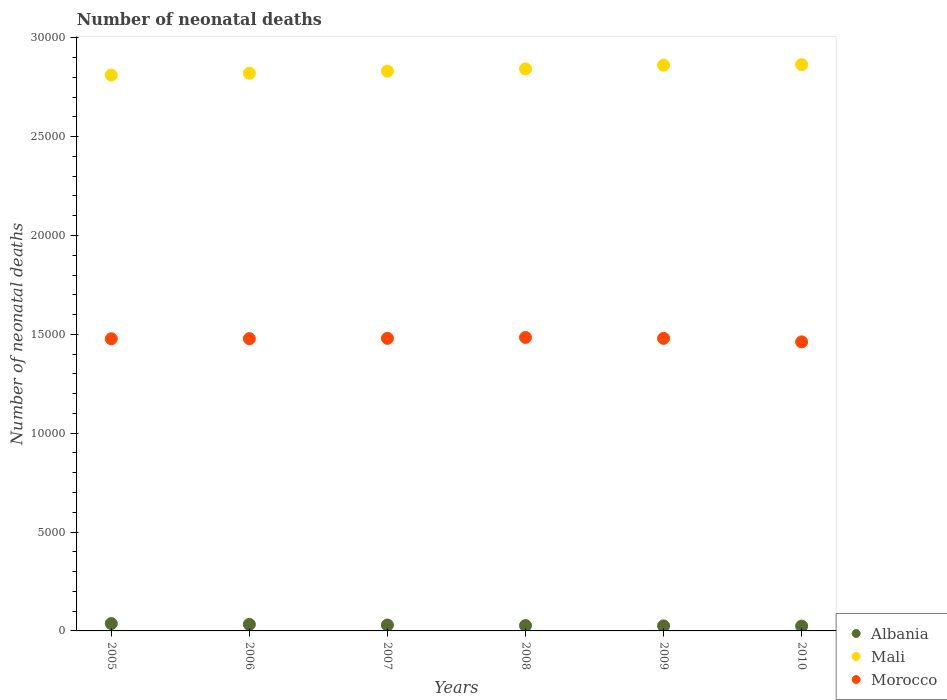How many different coloured dotlines are there?
Give a very brief answer. 3. Is the number of dotlines equal to the number of legend labels?
Keep it short and to the point. Yes. What is the number of neonatal deaths in in Mali in 2006?
Offer a terse response. 2.82e+04. Across all years, what is the maximum number of neonatal deaths in in Mali?
Make the answer very short. 2.86e+04. Across all years, what is the minimum number of neonatal deaths in in Mali?
Ensure brevity in your answer.  2.81e+04. In which year was the number of neonatal deaths in in Mali minimum?
Give a very brief answer. 2005. What is the total number of neonatal deaths in in Morocco in the graph?
Your answer should be very brief. 8.86e+04. What is the difference between the number of neonatal deaths in in Mali in 2006 and that in 2009?
Offer a very short reply. -407. What is the difference between the number of neonatal deaths in in Morocco in 2006 and the number of neonatal deaths in in Mali in 2007?
Your response must be concise. -1.35e+04. What is the average number of neonatal deaths in in Morocco per year?
Give a very brief answer. 1.48e+04. In the year 2008, what is the difference between the number of neonatal deaths in in Albania and number of neonatal deaths in in Morocco?
Provide a short and direct response. -1.46e+04. In how many years, is the number of neonatal deaths in in Albania greater than 25000?
Your answer should be compact. 0. What is the ratio of the number of neonatal deaths in in Morocco in 2006 to that in 2008?
Provide a succinct answer. 1. What is the difference between the highest and the second highest number of neonatal deaths in in Morocco?
Offer a very short reply. 44. What is the difference between the highest and the lowest number of neonatal deaths in in Albania?
Keep it short and to the point. 128. In how many years, is the number of neonatal deaths in in Mali greater than the average number of neonatal deaths in in Mali taken over all years?
Your response must be concise. 3. Is the sum of the number of neonatal deaths in in Morocco in 2008 and 2009 greater than the maximum number of neonatal deaths in in Mali across all years?
Your answer should be compact. Yes. Is it the case that in every year, the sum of the number of neonatal deaths in in Albania and number of neonatal deaths in in Mali  is greater than the number of neonatal deaths in in Morocco?
Make the answer very short. Yes. Does the number of neonatal deaths in in Mali monotonically increase over the years?
Offer a terse response. Yes. What is the difference between two consecutive major ticks on the Y-axis?
Offer a terse response. 5000. Are the values on the major ticks of Y-axis written in scientific E-notation?
Offer a very short reply. No. Where does the legend appear in the graph?
Make the answer very short. Bottom right. How many legend labels are there?
Your answer should be compact. 3. How are the legend labels stacked?
Your answer should be very brief. Vertical. What is the title of the graph?
Your response must be concise. Number of neonatal deaths. Does "Pacific island small states" appear as one of the legend labels in the graph?
Offer a terse response. No. What is the label or title of the X-axis?
Your answer should be very brief. Years. What is the label or title of the Y-axis?
Ensure brevity in your answer.  Number of neonatal deaths. What is the Number of neonatal deaths of Albania in 2005?
Offer a terse response. 372. What is the Number of neonatal deaths of Mali in 2005?
Your answer should be compact. 2.81e+04. What is the Number of neonatal deaths in Morocco in 2005?
Provide a short and direct response. 1.48e+04. What is the Number of neonatal deaths in Albania in 2006?
Give a very brief answer. 331. What is the Number of neonatal deaths in Mali in 2006?
Keep it short and to the point. 2.82e+04. What is the Number of neonatal deaths in Morocco in 2006?
Make the answer very short. 1.48e+04. What is the Number of neonatal deaths in Albania in 2007?
Your response must be concise. 297. What is the Number of neonatal deaths of Mali in 2007?
Provide a succinct answer. 2.83e+04. What is the Number of neonatal deaths in Morocco in 2007?
Give a very brief answer. 1.48e+04. What is the Number of neonatal deaths in Albania in 2008?
Ensure brevity in your answer.  271. What is the Number of neonatal deaths of Mali in 2008?
Your response must be concise. 2.84e+04. What is the Number of neonatal deaths of Morocco in 2008?
Provide a short and direct response. 1.48e+04. What is the Number of neonatal deaths of Albania in 2009?
Your response must be concise. 254. What is the Number of neonatal deaths in Mali in 2009?
Your answer should be very brief. 2.86e+04. What is the Number of neonatal deaths in Morocco in 2009?
Provide a succinct answer. 1.48e+04. What is the Number of neonatal deaths of Albania in 2010?
Your answer should be compact. 244. What is the Number of neonatal deaths in Mali in 2010?
Ensure brevity in your answer.  2.86e+04. What is the Number of neonatal deaths in Morocco in 2010?
Provide a succinct answer. 1.46e+04. Across all years, what is the maximum Number of neonatal deaths in Albania?
Keep it short and to the point. 372. Across all years, what is the maximum Number of neonatal deaths of Mali?
Offer a very short reply. 2.86e+04. Across all years, what is the maximum Number of neonatal deaths of Morocco?
Offer a terse response. 1.48e+04. Across all years, what is the minimum Number of neonatal deaths of Albania?
Provide a succinct answer. 244. Across all years, what is the minimum Number of neonatal deaths in Mali?
Your answer should be compact. 2.81e+04. Across all years, what is the minimum Number of neonatal deaths of Morocco?
Give a very brief answer. 1.46e+04. What is the total Number of neonatal deaths in Albania in the graph?
Provide a succinct answer. 1769. What is the total Number of neonatal deaths of Mali in the graph?
Offer a very short reply. 1.70e+05. What is the total Number of neonatal deaths of Morocco in the graph?
Your answer should be very brief. 8.86e+04. What is the difference between the Number of neonatal deaths of Mali in 2005 and that in 2006?
Your answer should be very brief. -95. What is the difference between the Number of neonatal deaths of Mali in 2005 and that in 2007?
Offer a terse response. -200. What is the difference between the Number of neonatal deaths of Albania in 2005 and that in 2008?
Provide a short and direct response. 101. What is the difference between the Number of neonatal deaths in Mali in 2005 and that in 2008?
Provide a succinct answer. -315. What is the difference between the Number of neonatal deaths in Morocco in 2005 and that in 2008?
Your response must be concise. -66. What is the difference between the Number of neonatal deaths of Albania in 2005 and that in 2009?
Your answer should be very brief. 118. What is the difference between the Number of neonatal deaths in Mali in 2005 and that in 2009?
Offer a terse response. -502. What is the difference between the Number of neonatal deaths of Albania in 2005 and that in 2010?
Make the answer very short. 128. What is the difference between the Number of neonatal deaths of Mali in 2005 and that in 2010?
Your answer should be very brief. -530. What is the difference between the Number of neonatal deaths in Morocco in 2005 and that in 2010?
Keep it short and to the point. 157. What is the difference between the Number of neonatal deaths of Albania in 2006 and that in 2007?
Offer a terse response. 34. What is the difference between the Number of neonatal deaths of Mali in 2006 and that in 2007?
Keep it short and to the point. -105. What is the difference between the Number of neonatal deaths in Mali in 2006 and that in 2008?
Your answer should be very brief. -220. What is the difference between the Number of neonatal deaths of Morocco in 2006 and that in 2008?
Offer a terse response. -60. What is the difference between the Number of neonatal deaths in Albania in 2006 and that in 2009?
Provide a short and direct response. 77. What is the difference between the Number of neonatal deaths of Mali in 2006 and that in 2009?
Provide a succinct answer. -407. What is the difference between the Number of neonatal deaths of Morocco in 2006 and that in 2009?
Make the answer very short. -16. What is the difference between the Number of neonatal deaths in Albania in 2006 and that in 2010?
Your answer should be compact. 87. What is the difference between the Number of neonatal deaths of Mali in 2006 and that in 2010?
Make the answer very short. -435. What is the difference between the Number of neonatal deaths in Morocco in 2006 and that in 2010?
Offer a very short reply. 163. What is the difference between the Number of neonatal deaths of Mali in 2007 and that in 2008?
Your response must be concise. -115. What is the difference between the Number of neonatal deaths in Morocco in 2007 and that in 2008?
Your answer should be compact. -44. What is the difference between the Number of neonatal deaths of Albania in 2007 and that in 2009?
Offer a terse response. 43. What is the difference between the Number of neonatal deaths in Mali in 2007 and that in 2009?
Offer a terse response. -302. What is the difference between the Number of neonatal deaths of Albania in 2007 and that in 2010?
Offer a very short reply. 53. What is the difference between the Number of neonatal deaths of Mali in 2007 and that in 2010?
Ensure brevity in your answer.  -330. What is the difference between the Number of neonatal deaths in Morocco in 2007 and that in 2010?
Keep it short and to the point. 179. What is the difference between the Number of neonatal deaths of Albania in 2008 and that in 2009?
Your answer should be very brief. 17. What is the difference between the Number of neonatal deaths of Mali in 2008 and that in 2009?
Give a very brief answer. -187. What is the difference between the Number of neonatal deaths of Morocco in 2008 and that in 2009?
Make the answer very short. 44. What is the difference between the Number of neonatal deaths of Albania in 2008 and that in 2010?
Ensure brevity in your answer.  27. What is the difference between the Number of neonatal deaths of Mali in 2008 and that in 2010?
Keep it short and to the point. -215. What is the difference between the Number of neonatal deaths in Morocco in 2008 and that in 2010?
Your response must be concise. 223. What is the difference between the Number of neonatal deaths in Albania in 2009 and that in 2010?
Ensure brevity in your answer.  10. What is the difference between the Number of neonatal deaths in Morocco in 2009 and that in 2010?
Give a very brief answer. 179. What is the difference between the Number of neonatal deaths in Albania in 2005 and the Number of neonatal deaths in Mali in 2006?
Offer a very short reply. -2.78e+04. What is the difference between the Number of neonatal deaths in Albania in 2005 and the Number of neonatal deaths in Morocco in 2006?
Give a very brief answer. -1.44e+04. What is the difference between the Number of neonatal deaths in Mali in 2005 and the Number of neonatal deaths in Morocco in 2006?
Make the answer very short. 1.33e+04. What is the difference between the Number of neonatal deaths of Albania in 2005 and the Number of neonatal deaths of Mali in 2007?
Provide a succinct answer. -2.79e+04. What is the difference between the Number of neonatal deaths in Albania in 2005 and the Number of neonatal deaths in Morocco in 2007?
Provide a succinct answer. -1.44e+04. What is the difference between the Number of neonatal deaths of Mali in 2005 and the Number of neonatal deaths of Morocco in 2007?
Your response must be concise. 1.33e+04. What is the difference between the Number of neonatal deaths of Albania in 2005 and the Number of neonatal deaths of Mali in 2008?
Provide a succinct answer. -2.81e+04. What is the difference between the Number of neonatal deaths in Albania in 2005 and the Number of neonatal deaths in Morocco in 2008?
Offer a very short reply. -1.45e+04. What is the difference between the Number of neonatal deaths in Mali in 2005 and the Number of neonatal deaths in Morocco in 2008?
Offer a terse response. 1.33e+04. What is the difference between the Number of neonatal deaths of Albania in 2005 and the Number of neonatal deaths of Mali in 2009?
Give a very brief answer. -2.82e+04. What is the difference between the Number of neonatal deaths in Albania in 2005 and the Number of neonatal deaths in Morocco in 2009?
Offer a terse response. -1.44e+04. What is the difference between the Number of neonatal deaths of Mali in 2005 and the Number of neonatal deaths of Morocco in 2009?
Make the answer very short. 1.33e+04. What is the difference between the Number of neonatal deaths of Albania in 2005 and the Number of neonatal deaths of Mali in 2010?
Your answer should be compact. -2.83e+04. What is the difference between the Number of neonatal deaths in Albania in 2005 and the Number of neonatal deaths in Morocco in 2010?
Make the answer very short. -1.42e+04. What is the difference between the Number of neonatal deaths in Mali in 2005 and the Number of neonatal deaths in Morocco in 2010?
Provide a short and direct response. 1.35e+04. What is the difference between the Number of neonatal deaths in Albania in 2006 and the Number of neonatal deaths in Mali in 2007?
Provide a succinct answer. -2.80e+04. What is the difference between the Number of neonatal deaths of Albania in 2006 and the Number of neonatal deaths of Morocco in 2007?
Provide a short and direct response. -1.45e+04. What is the difference between the Number of neonatal deaths of Mali in 2006 and the Number of neonatal deaths of Morocco in 2007?
Your answer should be very brief. 1.34e+04. What is the difference between the Number of neonatal deaths of Albania in 2006 and the Number of neonatal deaths of Mali in 2008?
Your answer should be compact. -2.81e+04. What is the difference between the Number of neonatal deaths of Albania in 2006 and the Number of neonatal deaths of Morocco in 2008?
Your answer should be compact. -1.45e+04. What is the difference between the Number of neonatal deaths in Mali in 2006 and the Number of neonatal deaths in Morocco in 2008?
Offer a very short reply. 1.34e+04. What is the difference between the Number of neonatal deaths of Albania in 2006 and the Number of neonatal deaths of Mali in 2009?
Offer a very short reply. -2.83e+04. What is the difference between the Number of neonatal deaths in Albania in 2006 and the Number of neonatal deaths in Morocco in 2009?
Provide a short and direct response. -1.45e+04. What is the difference between the Number of neonatal deaths of Mali in 2006 and the Number of neonatal deaths of Morocco in 2009?
Offer a terse response. 1.34e+04. What is the difference between the Number of neonatal deaths in Albania in 2006 and the Number of neonatal deaths in Mali in 2010?
Provide a short and direct response. -2.83e+04. What is the difference between the Number of neonatal deaths of Albania in 2006 and the Number of neonatal deaths of Morocco in 2010?
Offer a terse response. -1.43e+04. What is the difference between the Number of neonatal deaths of Mali in 2006 and the Number of neonatal deaths of Morocco in 2010?
Provide a succinct answer. 1.36e+04. What is the difference between the Number of neonatal deaths in Albania in 2007 and the Number of neonatal deaths in Mali in 2008?
Make the answer very short. -2.81e+04. What is the difference between the Number of neonatal deaths in Albania in 2007 and the Number of neonatal deaths in Morocco in 2008?
Offer a very short reply. -1.45e+04. What is the difference between the Number of neonatal deaths in Mali in 2007 and the Number of neonatal deaths in Morocco in 2008?
Your answer should be compact. 1.35e+04. What is the difference between the Number of neonatal deaths in Albania in 2007 and the Number of neonatal deaths in Mali in 2009?
Ensure brevity in your answer.  -2.83e+04. What is the difference between the Number of neonatal deaths in Albania in 2007 and the Number of neonatal deaths in Morocco in 2009?
Your response must be concise. -1.45e+04. What is the difference between the Number of neonatal deaths of Mali in 2007 and the Number of neonatal deaths of Morocco in 2009?
Provide a short and direct response. 1.35e+04. What is the difference between the Number of neonatal deaths in Albania in 2007 and the Number of neonatal deaths in Mali in 2010?
Offer a terse response. -2.83e+04. What is the difference between the Number of neonatal deaths of Albania in 2007 and the Number of neonatal deaths of Morocco in 2010?
Your answer should be compact. -1.43e+04. What is the difference between the Number of neonatal deaths in Mali in 2007 and the Number of neonatal deaths in Morocco in 2010?
Ensure brevity in your answer.  1.37e+04. What is the difference between the Number of neonatal deaths in Albania in 2008 and the Number of neonatal deaths in Mali in 2009?
Your answer should be compact. -2.83e+04. What is the difference between the Number of neonatal deaths in Albania in 2008 and the Number of neonatal deaths in Morocco in 2009?
Ensure brevity in your answer.  -1.45e+04. What is the difference between the Number of neonatal deaths of Mali in 2008 and the Number of neonatal deaths of Morocco in 2009?
Keep it short and to the point. 1.36e+04. What is the difference between the Number of neonatal deaths of Albania in 2008 and the Number of neonatal deaths of Mali in 2010?
Your answer should be compact. -2.84e+04. What is the difference between the Number of neonatal deaths of Albania in 2008 and the Number of neonatal deaths of Morocco in 2010?
Your answer should be very brief. -1.43e+04. What is the difference between the Number of neonatal deaths in Mali in 2008 and the Number of neonatal deaths in Morocco in 2010?
Your response must be concise. 1.38e+04. What is the difference between the Number of neonatal deaths in Albania in 2009 and the Number of neonatal deaths in Mali in 2010?
Provide a short and direct response. -2.84e+04. What is the difference between the Number of neonatal deaths in Albania in 2009 and the Number of neonatal deaths in Morocco in 2010?
Provide a short and direct response. -1.44e+04. What is the difference between the Number of neonatal deaths in Mali in 2009 and the Number of neonatal deaths in Morocco in 2010?
Your answer should be compact. 1.40e+04. What is the average Number of neonatal deaths in Albania per year?
Your answer should be very brief. 294.83. What is the average Number of neonatal deaths in Mali per year?
Ensure brevity in your answer.  2.84e+04. What is the average Number of neonatal deaths in Morocco per year?
Make the answer very short. 1.48e+04. In the year 2005, what is the difference between the Number of neonatal deaths in Albania and Number of neonatal deaths in Mali?
Make the answer very short. -2.77e+04. In the year 2005, what is the difference between the Number of neonatal deaths in Albania and Number of neonatal deaths in Morocco?
Ensure brevity in your answer.  -1.44e+04. In the year 2005, what is the difference between the Number of neonatal deaths of Mali and Number of neonatal deaths of Morocco?
Your response must be concise. 1.33e+04. In the year 2006, what is the difference between the Number of neonatal deaths of Albania and Number of neonatal deaths of Mali?
Make the answer very short. -2.79e+04. In the year 2006, what is the difference between the Number of neonatal deaths in Albania and Number of neonatal deaths in Morocco?
Keep it short and to the point. -1.45e+04. In the year 2006, what is the difference between the Number of neonatal deaths of Mali and Number of neonatal deaths of Morocco?
Keep it short and to the point. 1.34e+04. In the year 2007, what is the difference between the Number of neonatal deaths of Albania and Number of neonatal deaths of Mali?
Give a very brief answer. -2.80e+04. In the year 2007, what is the difference between the Number of neonatal deaths in Albania and Number of neonatal deaths in Morocco?
Make the answer very short. -1.45e+04. In the year 2007, what is the difference between the Number of neonatal deaths in Mali and Number of neonatal deaths in Morocco?
Keep it short and to the point. 1.35e+04. In the year 2008, what is the difference between the Number of neonatal deaths of Albania and Number of neonatal deaths of Mali?
Your answer should be compact. -2.82e+04. In the year 2008, what is the difference between the Number of neonatal deaths of Albania and Number of neonatal deaths of Morocco?
Give a very brief answer. -1.46e+04. In the year 2008, what is the difference between the Number of neonatal deaths in Mali and Number of neonatal deaths in Morocco?
Offer a very short reply. 1.36e+04. In the year 2009, what is the difference between the Number of neonatal deaths in Albania and Number of neonatal deaths in Mali?
Your answer should be compact. -2.84e+04. In the year 2009, what is the difference between the Number of neonatal deaths of Albania and Number of neonatal deaths of Morocco?
Your response must be concise. -1.45e+04. In the year 2009, what is the difference between the Number of neonatal deaths in Mali and Number of neonatal deaths in Morocco?
Provide a succinct answer. 1.38e+04. In the year 2010, what is the difference between the Number of neonatal deaths of Albania and Number of neonatal deaths of Mali?
Ensure brevity in your answer.  -2.84e+04. In the year 2010, what is the difference between the Number of neonatal deaths of Albania and Number of neonatal deaths of Morocco?
Give a very brief answer. -1.44e+04. In the year 2010, what is the difference between the Number of neonatal deaths in Mali and Number of neonatal deaths in Morocco?
Give a very brief answer. 1.40e+04. What is the ratio of the Number of neonatal deaths of Albania in 2005 to that in 2006?
Offer a terse response. 1.12. What is the ratio of the Number of neonatal deaths in Albania in 2005 to that in 2007?
Offer a terse response. 1.25. What is the ratio of the Number of neonatal deaths of Morocco in 2005 to that in 2007?
Ensure brevity in your answer.  1. What is the ratio of the Number of neonatal deaths in Albania in 2005 to that in 2008?
Offer a very short reply. 1.37. What is the ratio of the Number of neonatal deaths of Mali in 2005 to that in 2008?
Provide a short and direct response. 0.99. What is the ratio of the Number of neonatal deaths of Albania in 2005 to that in 2009?
Ensure brevity in your answer.  1.46. What is the ratio of the Number of neonatal deaths in Mali in 2005 to that in 2009?
Offer a very short reply. 0.98. What is the ratio of the Number of neonatal deaths in Albania in 2005 to that in 2010?
Keep it short and to the point. 1.52. What is the ratio of the Number of neonatal deaths in Mali in 2005 to that in 2010?
Give a very brief answer. 0.98. What is the ratio of the Number of neonatal deaths in Morocco in 2005 to that in 2010?
Your answer should be compact. 1.01. What is the ratio of the Number of neonatal deaths of Albania in 2006 to that in 2007?
Offer a terse response. 1.11. What is the ratio of the Number of neonatal deaths in Albania in 2006 to that in 2008?
Ensure brevity in your answer.  1.22. What is the ratio of the Number of neonatal deaths in Morocco in 2006 to that in 2008?
Offer a terse response. 1. What is the ratio of the Number of neonatal deaths in Albania in 2006 to that in 2009?
Ensure brevity in your answer.  1.3. What is the ratio of the Number of neonatal deaths of Mali in 2006 to that in 2009?
Your response must be concise. 0.99. What is the ratio of the Number of neonatal deaths in Albania in 2006 to that in 2010?
Make the answer very short. 1.36. What is the ratio of the Number of neonatal deaths in Morocco in 2006 to that in 2010?
Keep it short and to the point. 1.01. What is the ratio of the Number of neonatal deaths of Albania in 2007 to that in 2008?
Keep it short and to the point. 1.1. What is the ratio of the Number of neonatal deaths in Mali in 2007 to that in 2008?
Offer a terse response. 1. What is the ratio of the Number of neonatal deaths in Morocco in 2007 to that in 2008?
Offer a terse response. 1. What is the ratio of the Number of neonatal deaths of Albania in 2007 to that in 2009?
Offer a terse response. 1.17. What is the ratio of the Number of neonatal deaths in Morocco in 2007 to that in 2009?
Your response must be concise. 1. What is the ratio of the Number of neonatal deaths of Albania in 2007 to that in 2010?
Your answer should be very brief. 1.22. What is the ratio of the Number of neonatal deaths in Morocco in 2007 to that in 2010?
Ensure brevity in your answer.  1.01. What is the ratio of the Number of neonatal deaths of Albania in 2008 to that in 2009?
Provide a short and direct response. 1.07. What is the ratio of the Number of neonatal deaths in Albania in 2008 to that in 2010?
Your answer should be compact. 1.11. What is the ratio of the Number of neonatal deaths in Morocco in 2008 to that in 2010?
Your answer should be very brief. 1.02. What is the ratio of the Number of neonatal deaths in Albania in 2009 to that in 2010?
Provide a succinct answer. 1.04. What is the ratio of the Number of neonatal deaths in Morocco in 2009 to that in 2010?
Ensure brevity in your answer.  1.01. What is the difference between the highest and the lowest Number of neonatal deaths of Albania?
Make the answer very short. 128. What is the difference between the highest and the lowest Number of neonatal deaths in Mali?
Keep it short and to the point. 530. What is the difference between the highest and the lowest Number of neonatal deaths in Morocco?
Provide a succinct answer. 223. 